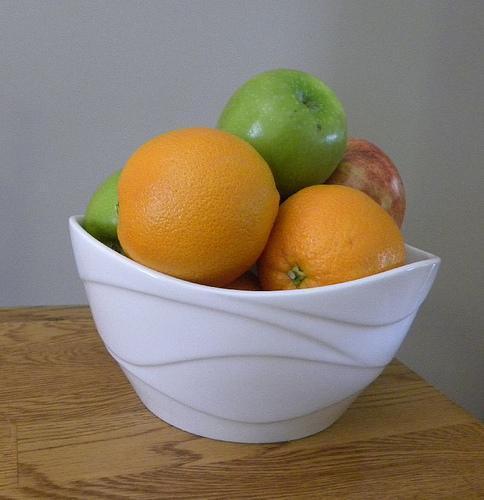How many bowls are there?
Give a very brief answer. 1. How many red pieces of red fruit is there?
Give a very brief answer. 1. How many oranges are visible?
Give a very brief answer. 2. How many pineapples are in the bowl?
Give a very brief answer. 0. How many elephants are pictured?
Give a very brief answer. 0. 